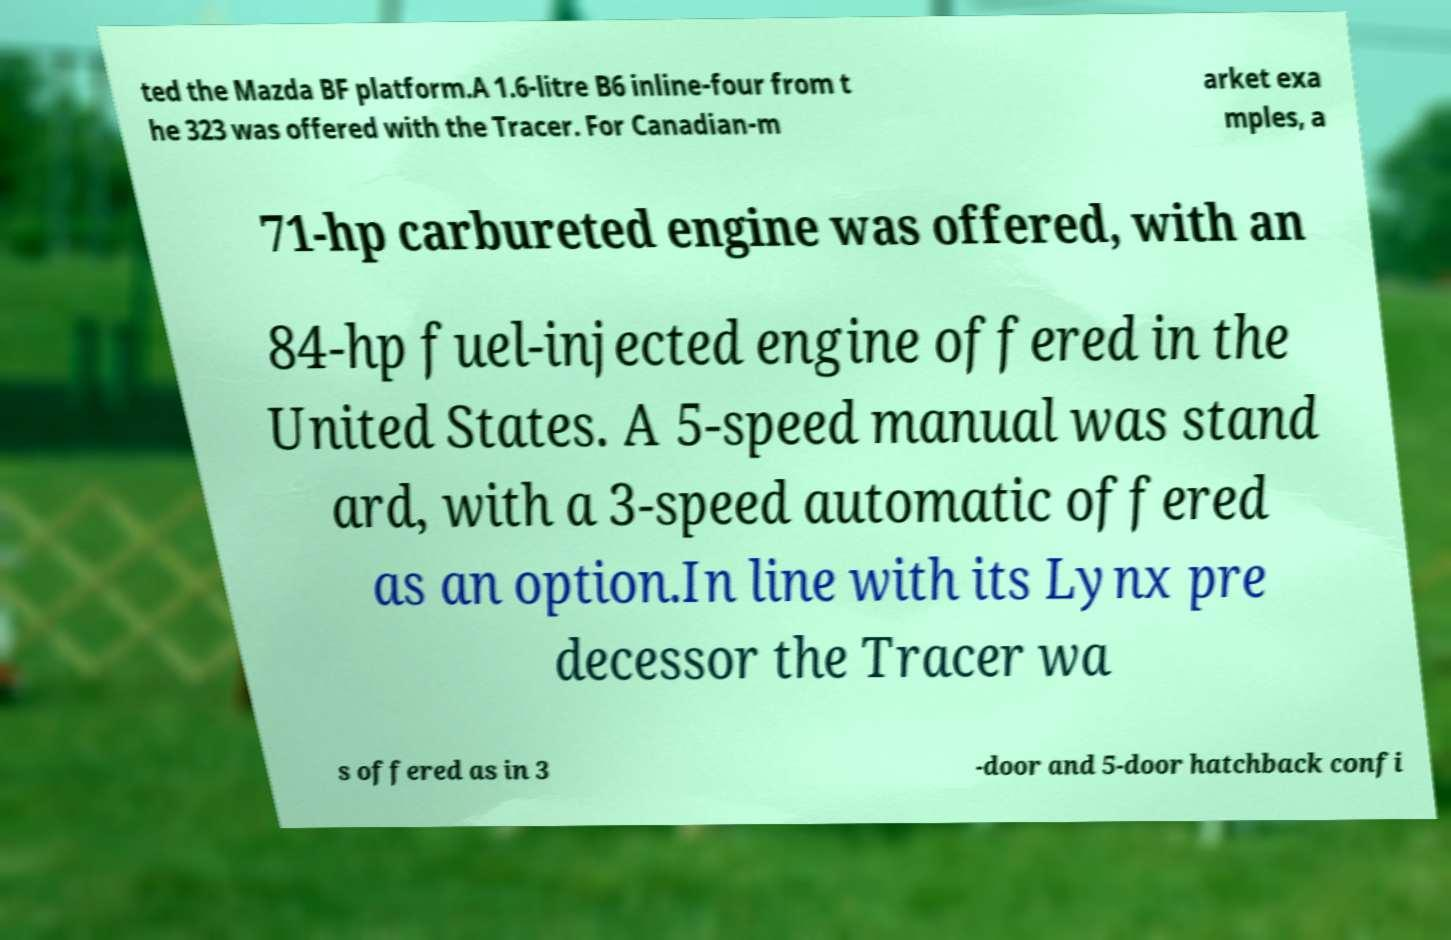Can you read and provide the text displayed in the image?This photo seems to have some interesting text. Can you extract and type it out for me? ted the Mazda BF platform.A 1.6-litre B6 inline-four from t he 323 was offered with the Tracer. For Canadian-m arket exa mples, a 71-hp carbureted engine was offered, with an 84-hp fuel-injected engine offered in the United States. A 5-speed manual was stand ard, with a 3-speed automatic offered as an option.In line with its Lynx pre decessor the Tracer wa s offered as in 3 -door and 5-door hatchback confi 